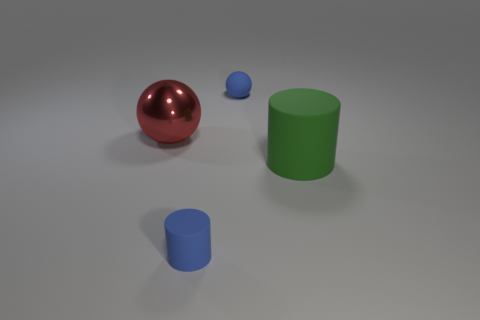Add 4 tiny purple matte spheres. How many objects exist? 8 Subtract all blue cylinders. How many cylinders are left? 1 Subtract 2 spheres. How many spheres are left? 0 Add 1 big green shiny cubes. How many big green shiny cubes exist? 1 Subtract 0 brown cylinders. How many objects are left? 4 Subtract all red spheres. Subtract all brown cylinders. How many spheres are left? 1 Subtract all yellow balls. How many blue cylinders are left? 1 Subtract all large metal objects. Subtract all brown matte balls. How many objects are left? 3 Add 3 small spheres. How many small spheres are left? 4 